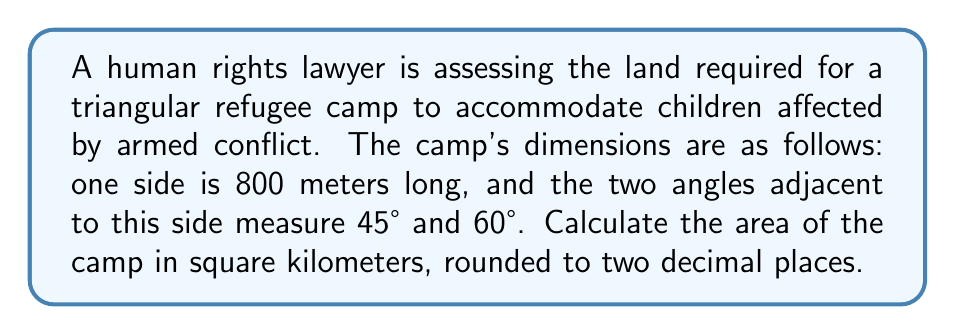Could you help me with this problem? To solve this problem, we'll use trigonometric formulas to find the area of the triangular camp. Let's approach this step-by-step:

1) We're given a triangle with one side (a) = 800 meters, and two angles: A = 45° and B = 60°.

2) To find the area, we can use the formula:
   $$ \text{Area} = \frac{1}{2} a b \sin C $$
   where a and b are two sides, and C is the angle between them.

3) We know a = 800m, but we need to find b and C.

4) First, let's find C:
   $$ C = 180° - (A + B) = 180° - (45° + 60°) = 75° $$

5) Now, to find b, we can use the sine law:
   $$ \frac{a}{\sin A} = \frac{b}{\sin B} $$

6) Rearranging to solve for b:
   $$ b = \frac{a \sin B}{\sin A} = \frac{800 \sin 60°}{\sin 45°} $$

7) Calculate:
   $$ b = \frac{800 \cdot \frac{\sqrt{3}}{2}}{\frac{\sqrt{2}}{2}} = 800 \cdot \frac{\sqrt{3}}{\sqrt{2}} \approx 979.80 \text{ meters} $$

8) Now we can use the area formula:
   $$ \text{Area} = \frac{1}{2} \cdot 800 \cdot 979.80 \cdot \sin 75° $$

9) Calculate:
   $$ \text{Area} \approx 378,735.68 \text{ square meters} $$

10) Convert to square kilometers:
    $$ 378,735.68 \text{ m}^2 = 0.37873568 \text{ km}^2 $$

11) Rounding to two decimal places: 0.38 km²
Answer: 0.38 km² 